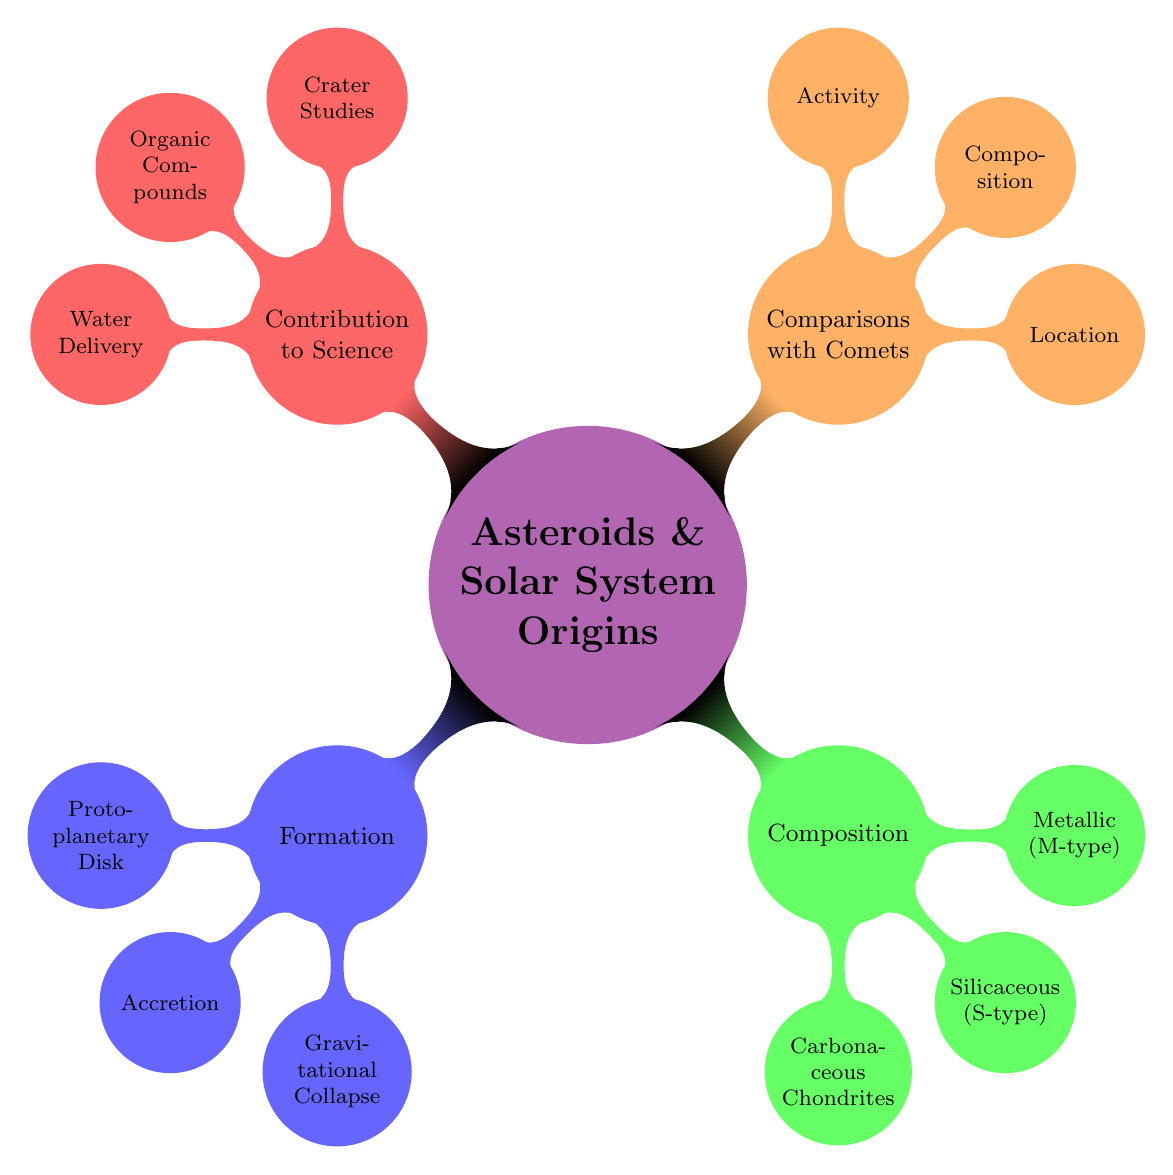What are the three main processes of asteroid formation? The diagram shows that asteroid formation consists of three main processes: Protoplanetary Disk, Accretion, and Gravitational Collapse.
Answer: Protoplanetary Disk, Accretion, Gravitational Collapse How are asteroids primarily composed? Referring to the composition section in the diagram, asteroids are primarily made of rock and metal, which corresponds to the S-type and M-type asteroids mentioned.
Answer: Rock and metal Where do asteroids originate in the Solar System? The location of asteroids is specified in the Comparisons with Comets section, indicating that they are mostly found in the Asteroid Belt, which is between Mars and Jupiter.
Answer: Asteroid Belt What is the primary difference in activity between asteroids and comets? The diagram explains that asteroids are generally inactive while comets display a coma and tails when they are near the Sun, showcasing a key difference in their behavior.
Answer: Generally inactive Which type of asteroid contains water and organic materials? Based on the Composition section, the diagram specifies that Carbonaceous Chondrites are the type of asteroid that contains water and organic materials.
Answer: Carbonaceous Chondrites What contribution do asteroids make to our understanding of organic compounds? The Contribution to Planetary Science section states that asteroids contribute by providing organic compounds, which are essential as building blocks of life.
Answer: Organic Compounds How many main types of asteroids are listed in the composition section? The Composition section lists three types of asteroids: Carbonaceous Chondrites, Silicaceous (S-type), and Metallic (M-type), making a total of three independent classifications.
Answer: Three What is the theory regarding water delivery linked to asteroids? The diagram indicates that asteroids have a theory associated with them regarding the delivery of water to early Earth, which is highlighted in the Contribution to Planetary Science section.
Answer: Delivery of Water 